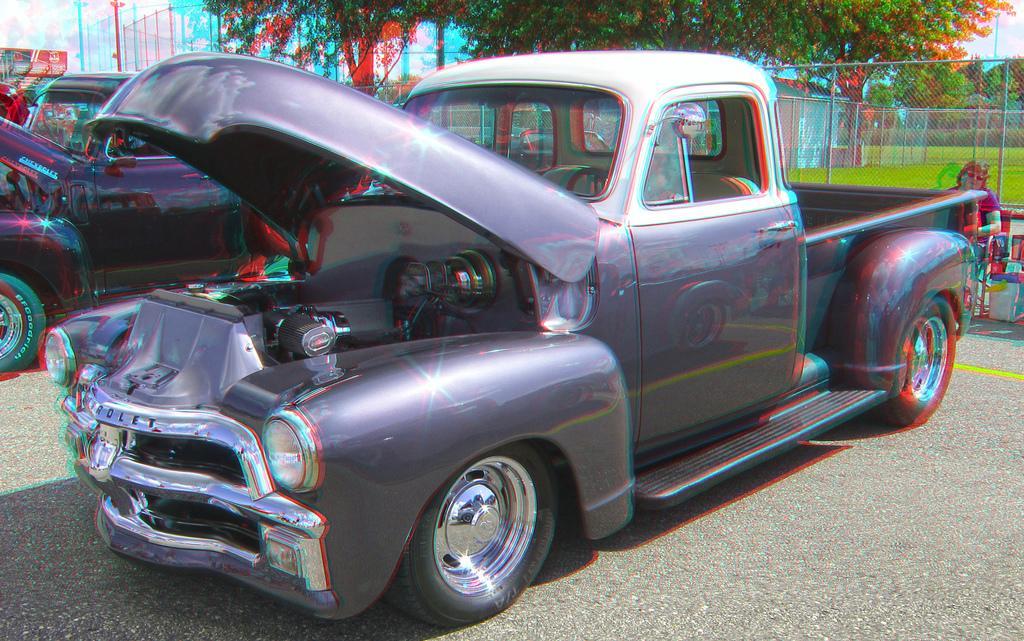How would you summarize this image in a sentence or two? In the picture we can see a vintage car which is violet in color parked on the road and besides also we can see some cars parked and in the background, we can see some fencing wall with poles and behind we can see some grass and trees. 